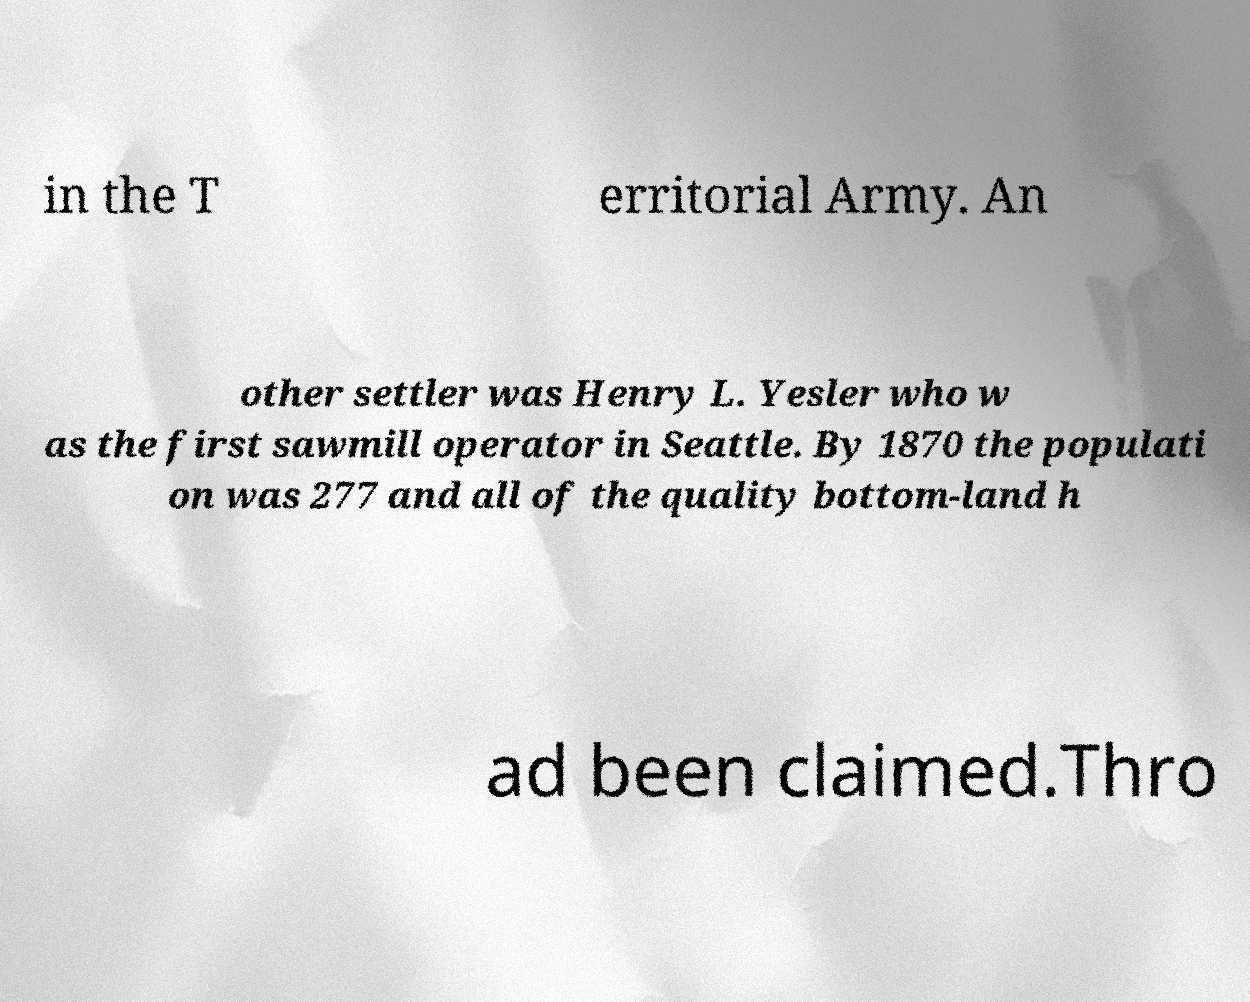Please read and relay the text visible in this image. What does it say? in the T erritorial Army. An other settler was Henry L. Yesler who w as the first sawmill operator in Seattle. By 1870 the populati on was 277 and all of the quality bottom-land h ad been claimed.Thro 